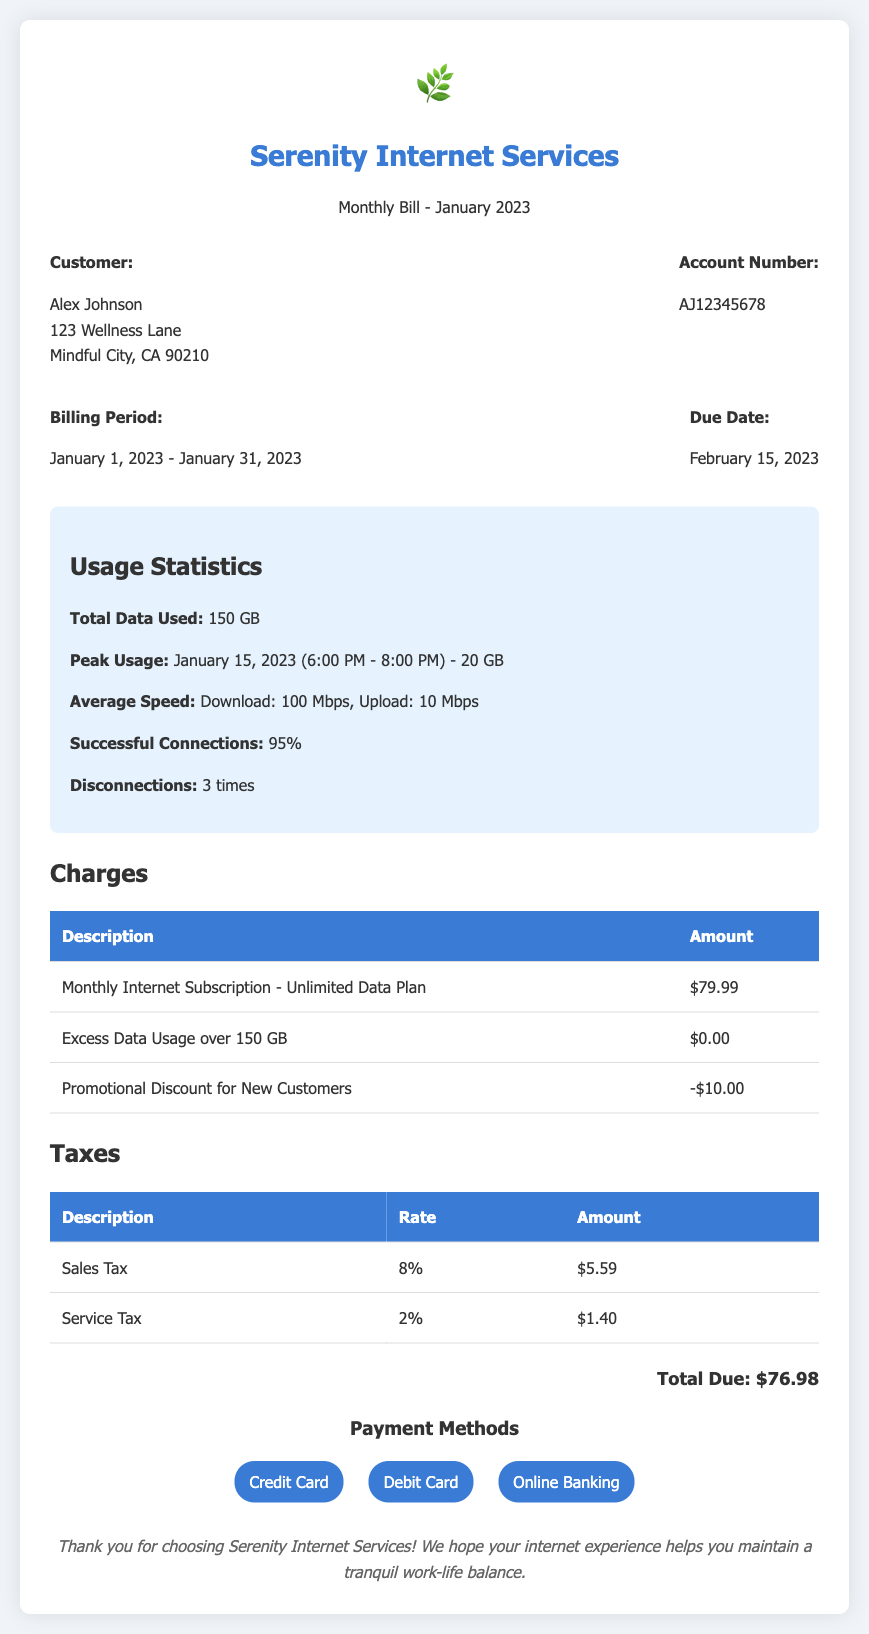What is the total data used in January 2023? The total data used is stated in the usage statistics section of the bill.
Answer: 150 GB What is the due date for the bill? The due date is provided in the billing information section of the document.
Answer: February 15, 2023 What is the account number for the customer? The account number can be found in the customer information section of the bill.
Answer: AJ12345678 What promotional discount was applied to the bill? The promotional discount amount is detailed in the charges section of the bill.
Answer: -$10.00 How many times did disconnections occur in January? The number of disconnections is mentioned in the usage statistics section of the bill.
Answer: 3 times What is the total amount due for the bill? The total due is clearly stated at the end of the charges and taxes sections.
Answer: $76.98 What are the payment methods available? The payment methods are listed in the payment methods section of the bill.
Answer: Credit Card, Debit Card, Online Banking What was the average upload speed reported? The average upload speed is included in the usage statistics section of the bill.
Answer: 10 Mbps What percentage of successful connections were recorded? The percentage of successful connections is provided in the usage statistics section of the document.
Answer: 95% 